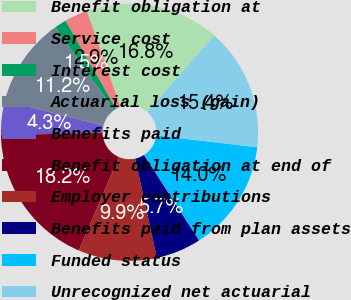Convert chart. <chart><loc_0><loc_0><loc_500><loc_500><pie_chart><fcel>Benefit obligation at<fcel>Service cost<fcel>Interest cost<fcel>Actuarial loss (gain)<fcel>Benefits paid<fcel>Benefit obligation at end of<fcel>Employer contributions<fcel>Benefits paid from plan assets<fcel>Funded status<fcel>Unrecognized net actuarial<nl><fcel>16.82%<fcel>2.9%<fcel>1.51%<fcel>11.25%<fcel>4.3%<fcel>18.21%<fcel>9.86%<fcel>5.69%<fcel>14.04%<fcel>15.43%<nl></chart> 